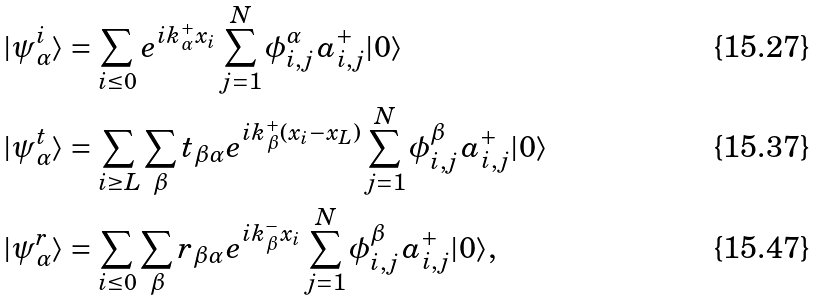<formula> <loc_0><loc_0><loc_500><loc_500>| \psi _ { \alpha } ^ { i } \rangle & = \sum _ { i \leq 0 } e ^ { i k _ { \alpha } ^ { + } x _ { i } } \sum _ { j = 1 } ^ { N } \phi _ { i , j } ^ { \alpha } \, a _ { i , j } ^ { + } | 0 \rangle \\ | \psi _ { \alpha } ^ { t } \rangle & = \sum _ { i \geq L } \sum _ { \beta } t _ { \beta \alpha } e ^ { i k _ { \beta } ^ { + } ( x _ { i } - x _ { L } ) } \sum _ { j = 1 } ^ { N } \phi _ { i , j } ^ { \beta } \, a _ { i , j } ^ { + } | 0 \rangle \\ | \psi _ { \alpha } ^ { r } \rangle & = \sum _ { i \leq 0 } \sum _ { \beta } r _ { \beta \alpha } e ^ { i k _ { \beta } ^ { - } x _ { i } } \sum _ { j = 1 } ^ { N } \phi _ { i , j } ^ { \beta } \, a _ { i , j } ^ { + } | 0 \rangle ,</formula> 